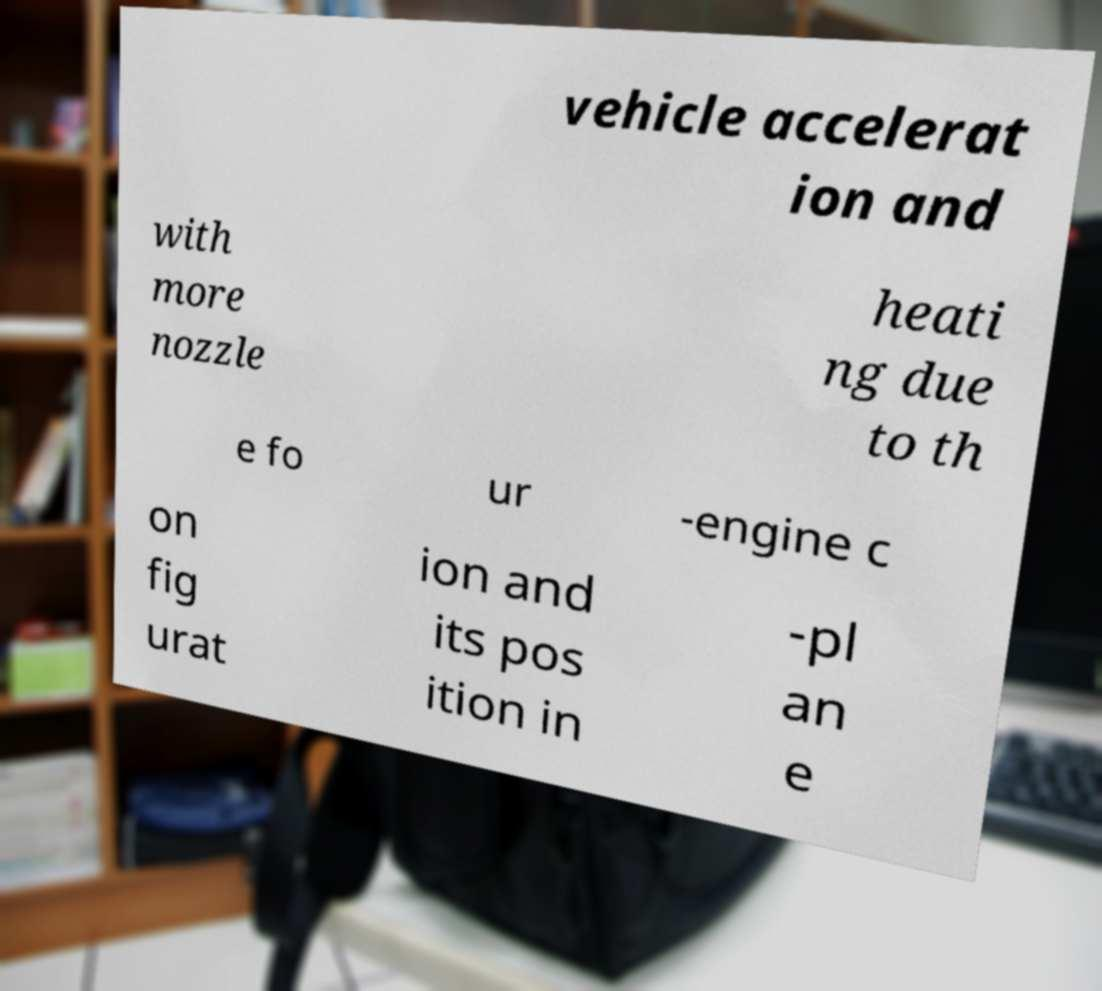Please identify and transcribe the text found in this image. vehicle accelerat ion and with more nozzle heati ng due to th e fo ur -engine c on fig urat ion and its pos ition in -pl an e 